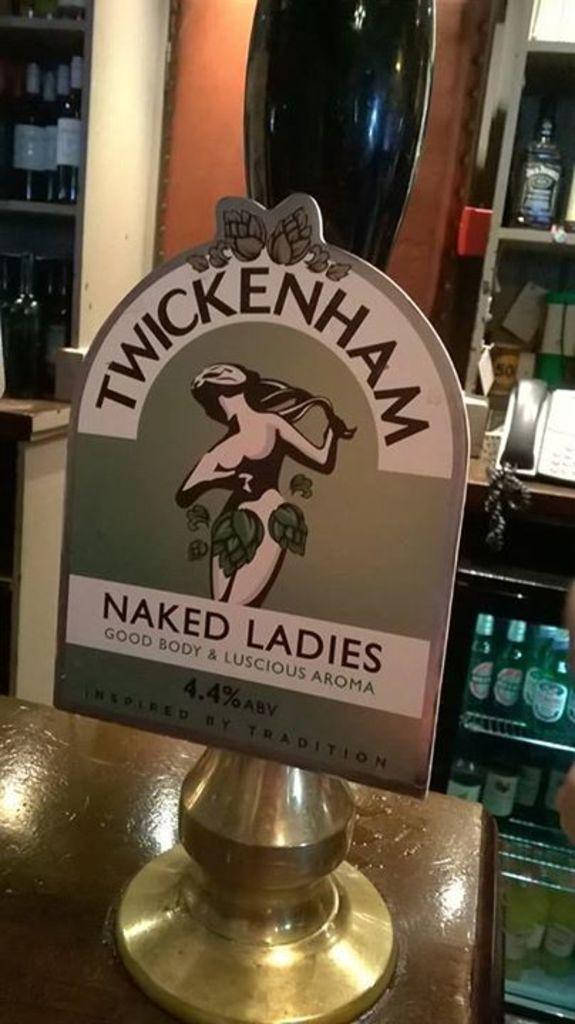<image>
Relay a brief, clear account of the picture shown. A bar tap contains a beer titled naked ladies. 